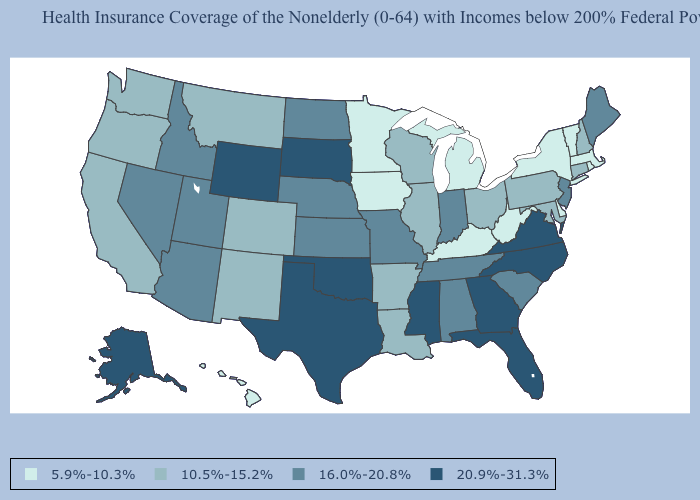Does California have the highest value in the West?
Quick response, please. No. What is the value of Illinois?
Short answer required. 10.5%-15.2%. Which states hav the highest value in the West?
Write a very short answer. Alaska, Wyoming. What is the lowest value in states that border Florida?
Be succinct. 16.0%-20.8%. Name the states that have a value in the range 20.9%-31.3%?
Concise answer only. Alaska, Florida, Georgia, Mississippi, North Carolina, Oklahoma, South Dakota, Texas, Virginia, Wyoming. Name the states that have a value in the range 10.5%-15.2%?
Be succinct. Arkansas, California, Colorado, Connecticut, Illinois, Louisiana, Maryland, Montana, New Hampshire, New Mexico, Ohio, Oregon, Pennsylvania, Washington, Wisconsin. Is the legend a continuous bar?
Give a very brief answer. No. What is the value of Delaware?
Quick response, please. 5.9%-10.3%. What is the value of Vermont?
Quick response, please. 5.9%-10.3%. What is the value of New Jersey?
Short answer required. 16.0%-20.8%. What is the value of Washington?
Give a very brief answer. 10.5%-15.2%. Does Oregon have a higher value than Minnesota?
Answer briefly. Yes. Name the states that have a value in the range 10.5%-15.2%?
Be succinct. Arkansas, California, Colorado, Connecticut, Illinois, Louisiana, Maryland, Montana, New Hampshire, New Mexico, Ohio, Oregon, Pennsylvania, Washington, Wisconsin. Which states have the lowest value in the MidWest?
Concise answer only. Iowa, Michigan, Minnesota. 